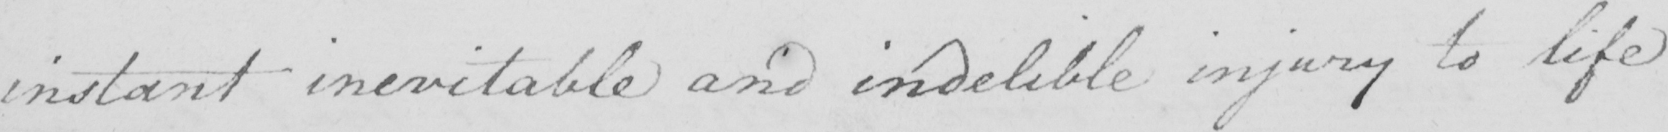What is written in this line of handwriting? instant inevitable and indelible injury to life 